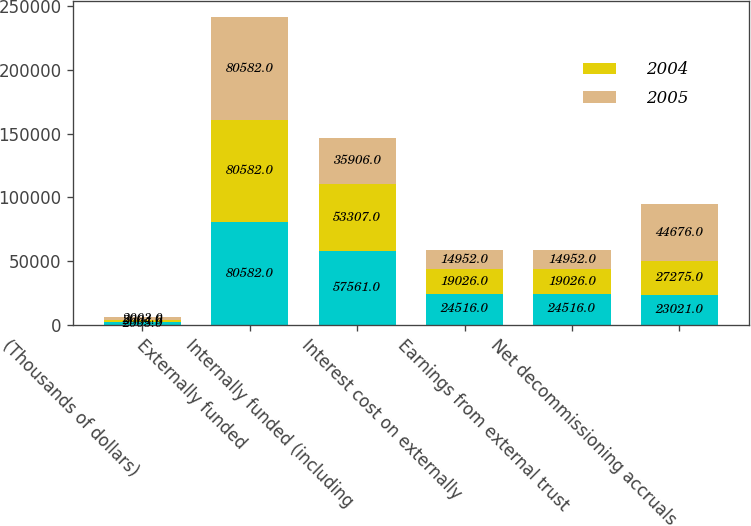<chart> <loc_0><loc_0><loc_500><loc_500><stacked_bar_chart><ecel><fcel>(Thousands of dollars)<fcel>Externally funded<fcel>Internally funded (including<fcel>Interest cost on externally<fcel>Earnings from external trust<fcel>Net decommissioning accruals<nl><fcel>nan<fcel>2005<fcel>80582<fcel>57561<fcel>24516<fcel>24516<fcel>23021<nl><fcel>2004<fcel>2004<fcel>80582<fcel>53307<fcel>19026<fcel>19026<fcel>27275<nl><fcel>2005<fcel>2003<fcel>80582<fcel>35906<fcel>14952<fcel>14952<fcel>44676<nl></chart> 